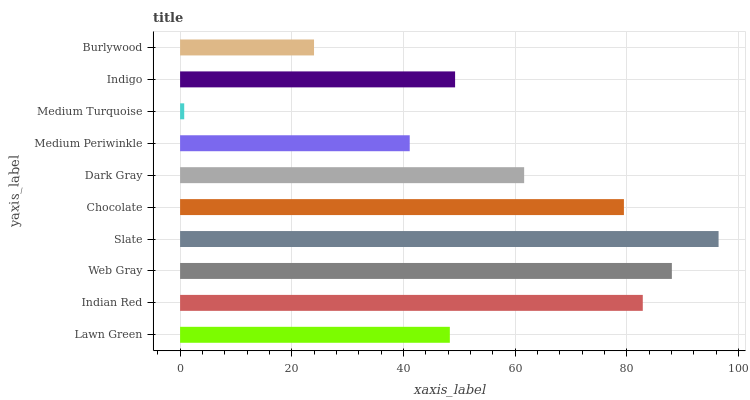Is Medium Turquoise the minimum?
Answer yes or no. Yes. Is Slate the maximum?
Answer yes or no. Yes. Is Indian Red the minimum?
Answer yes or no. No. Is Indian Red the maximum?
Answer yes or no. No. Is Indian Red greater than Lawn Green?
Answer yes or no. Yes. Is Lawn Green less than Indian Red?
Answer yes or no. Yes. Is Lawn Green greater than Indian Red?
Answer yes or no. No. Is Indian Red less than Lawn Green?
Answer yes or no. No. Is Dark Gray the high median?
Answer yes or no. Yes. Is Indigo the low median?
Answer yes or no. Yes. Is Medium Turquoise the high median?
Answer yes or no. No. Is Medium Periwinkle the low median?
Answer yes or no. No. 